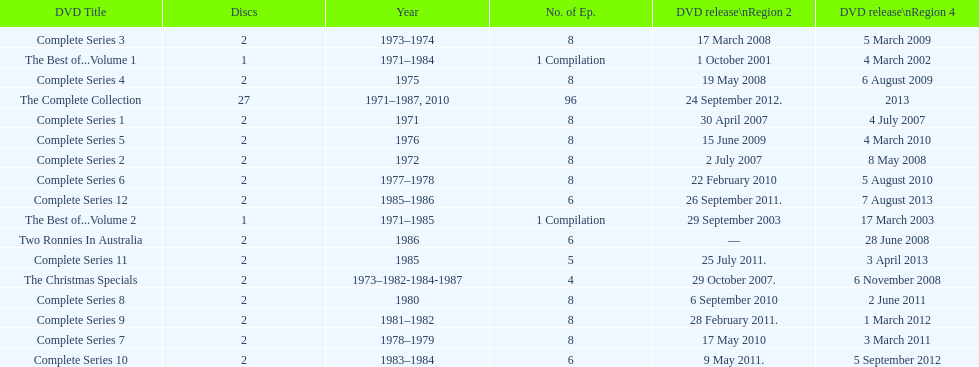Which element precedes the completion of series 10? Complete Series 9. 